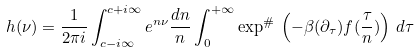Convert formula to latex. <formula><loc_0><loc_0><loc_500><loc_500>h ( \nu ) = \frac { 1 } { 2 \pi i } \int _ { c - i \infty } ^ { c + i \infty } e ^ { n \nu } \frac { d n } { n } \int _ { 0 } ^ { + \infty } \exp ^ { \# } \, \left ( - \beta ( \partial _ { \tau } ) f ( \frac { \tau } { n } ) \right ) \, d \tau</formula> 